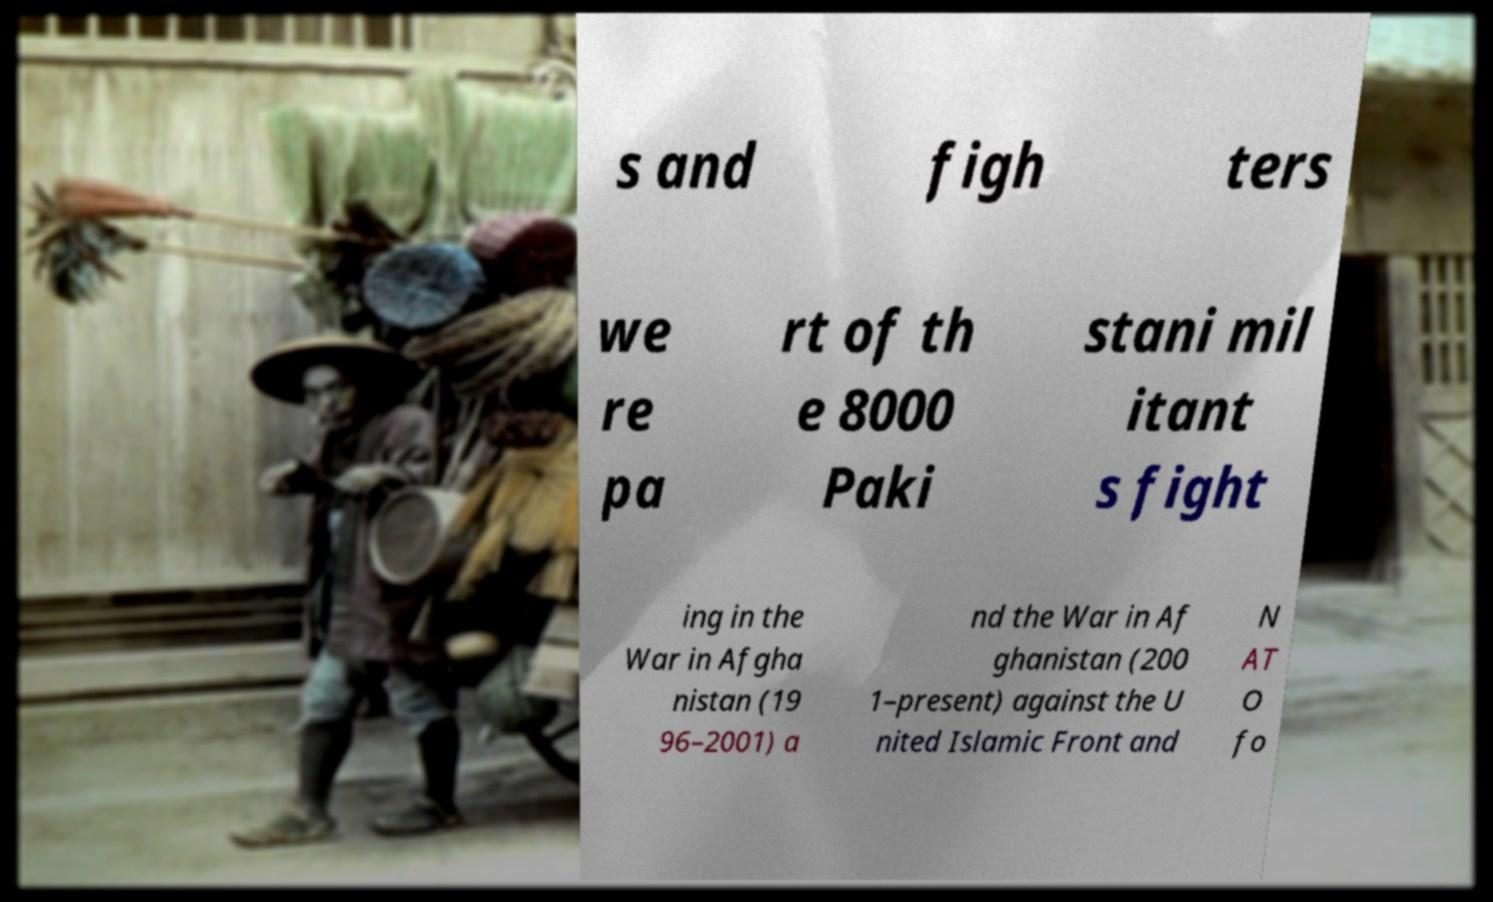What messages or text are displayed in this image? I need them in a readable, typed format. s and figh ters we re pa rt of th e 8000 Paki stani mil itant s fight ing in the War in Afgha nistan (19 96–2001) a nd the War in Af ghanistan (200 1–present) against the U nited Islamic Front and N AT O fo 